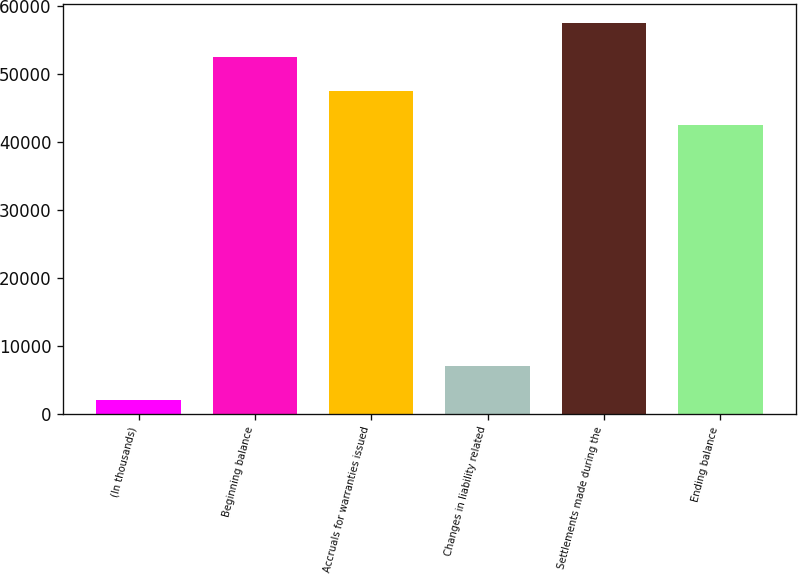<chart> <loc_0><loc_0><loc_500><loc_500><bar_chart><fcel>(In thousands)<fcel>Beginning balance<fcel>Accruals for warranties issued<fcel>Changes in liability related<fcel>Settlements made during the<fcel>Ending balance<nl><fcel>2013<fcel>52538.6<fcel>47570.8<fcel>6980.8<fcel>57506.4<fcel>42603<nl></chart> 